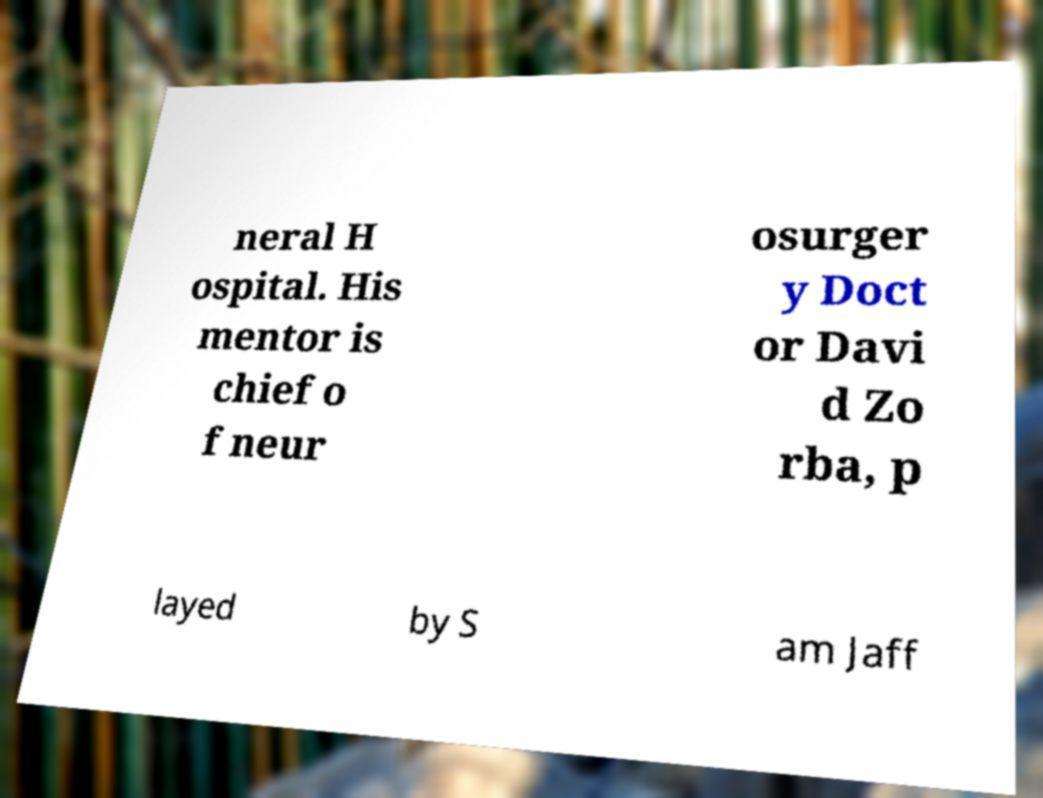Please identify and transcribe the text found in this image. neral H ospital. His mentor is chief o f neur osurger y Doct or Davi d Zo rba, p layed by S am Jaff 